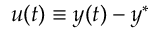Convert formula to latex. <formula><loc_0><loc_0><loc_500><loc_500>u ( t ) \equiv y ( t ) - y ^ { * }</formula> 